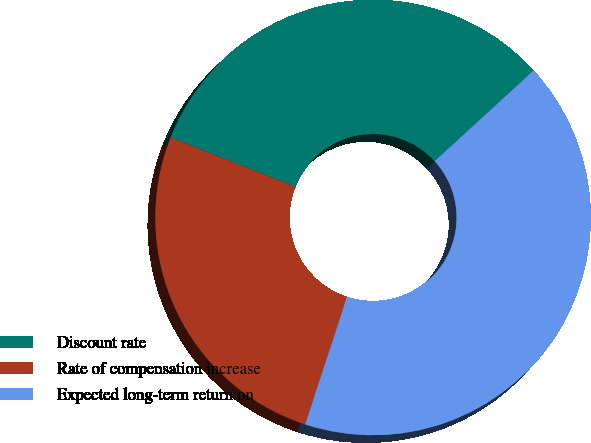Convert chart to OTSL. <chart><loc_0><loc_0><loc_500><loc_500><pie_chart><fcel>Discount rate<fcel>Rate of compensation increase<fcel>Expected long-term return on<nl><fcel>32.2%<fcel>25.96%<fcel>41.84%<nl></chart> 